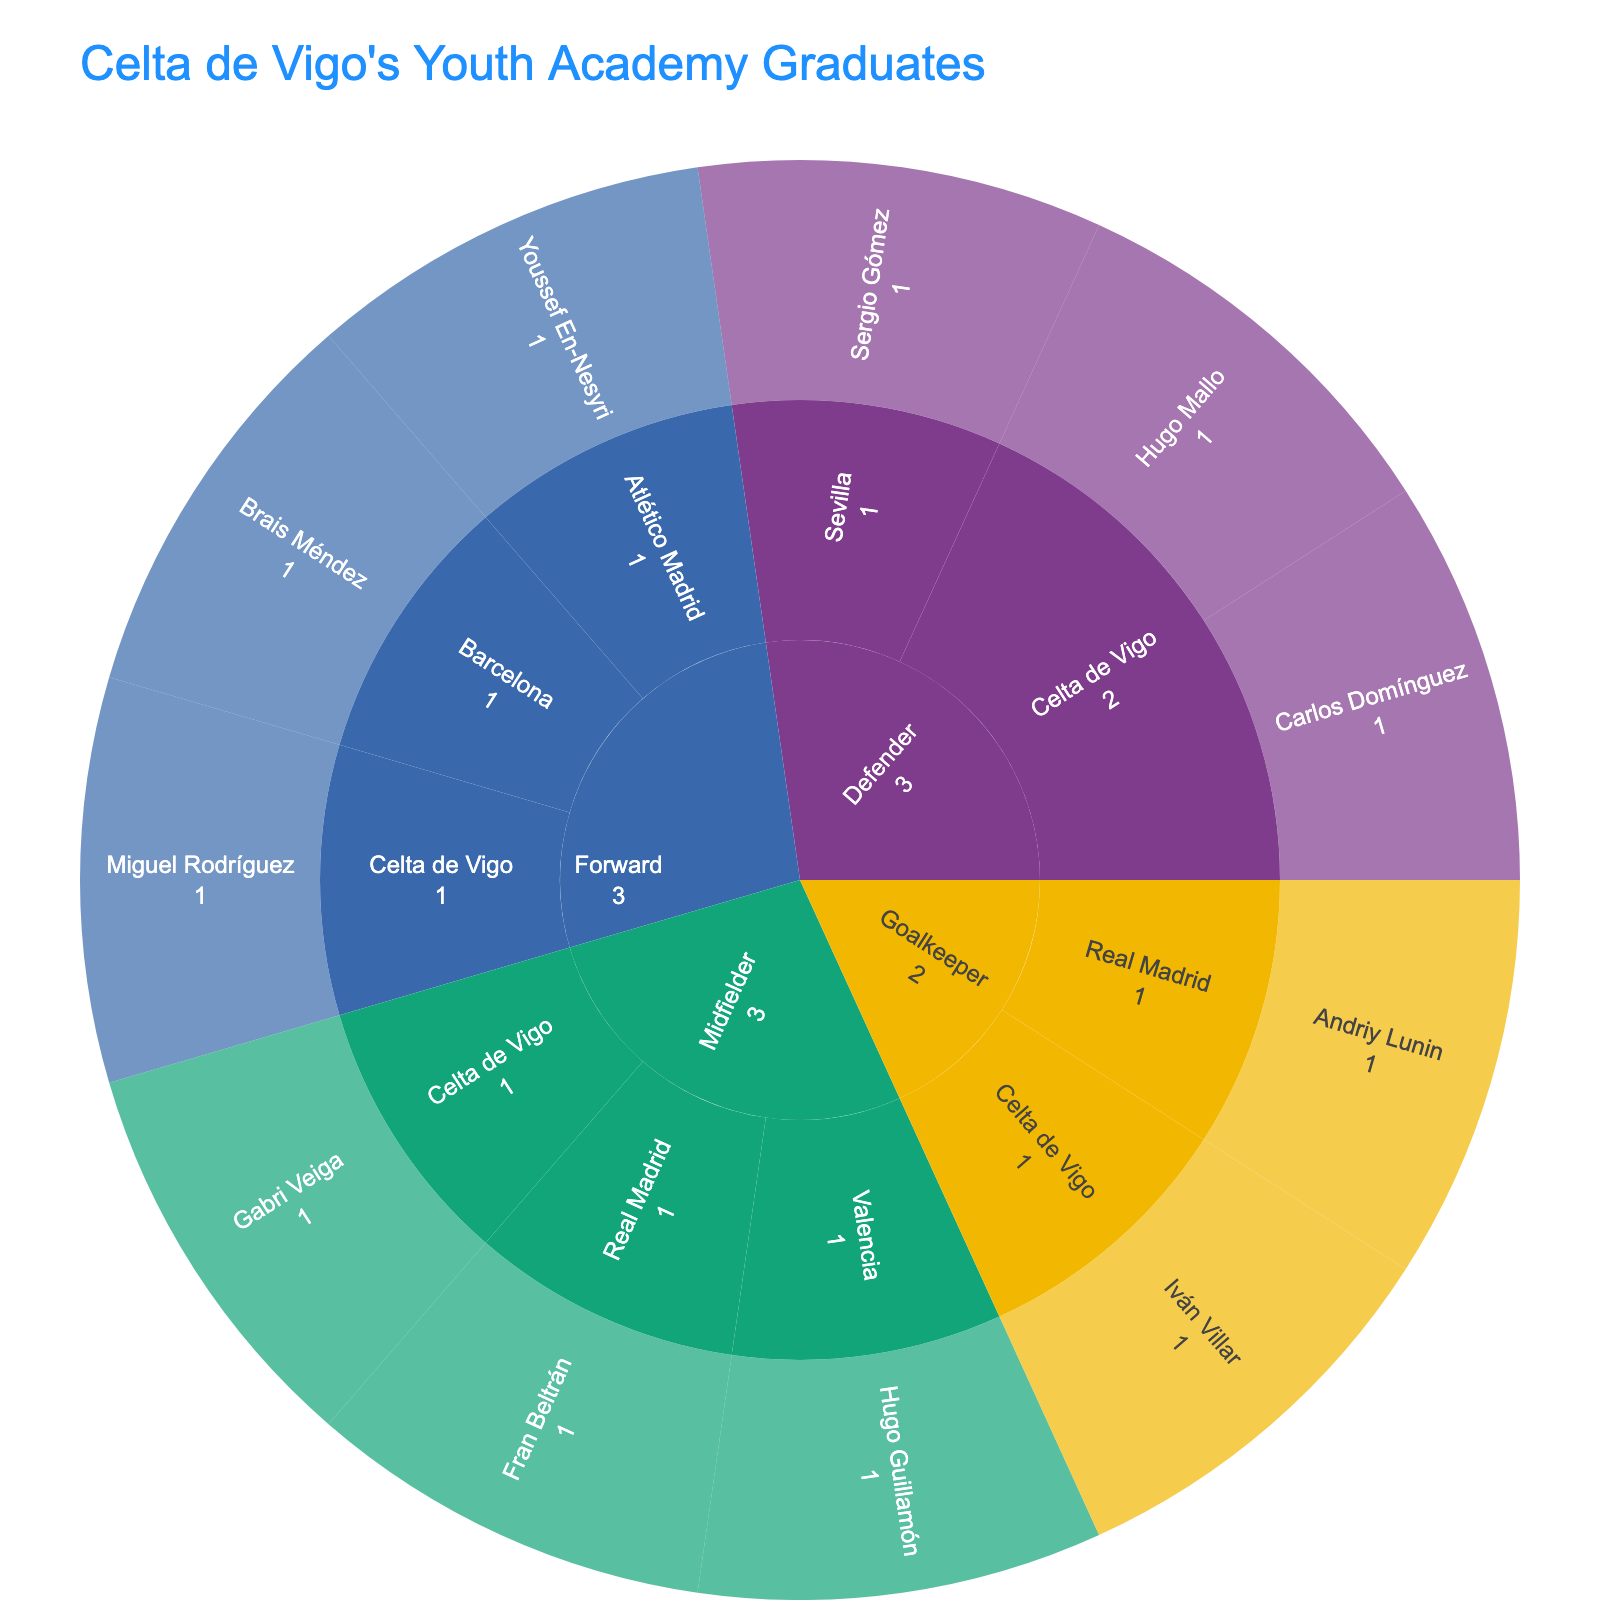What is the title of the Sunburst Plot? The title is usually located at the top of the plot and summarizes the main subject.
Answer: Celta de Vigo's Youth Academy Graduates How many midfielders are currently playing for Celta de Vigo? Navigate through the Midfielder section and check the segment for players at Celta de Vigo. Count the players listed.
Answer: 1 Which player from the youth academy is a goalkeeper at Real Madrid? Navigate to the Goalkeeper section and find the segment for Real Madrid. The player's name will be listed there.
Answer: Andriy Lunin Are there more forwards or defenders currently at Celta de Vigo? Navigate to the Forward and Defender sections and count the players listed under Celta de Vigo in each section. Compare the counts.
Answer: Defenders How many players from the youth academy are currently playing for Real Madrid? Navigate through the plot to identify all segments under Real Madrid across different positions and count the players listed there.
Answer: 2 Compare the number of midfielders at Celta de Vigo versus those at Valencia. Navigate to the Midfielder section and count the players listed under both Celta de Vigo and Valencia segments. Compare the counts.
Answer: 1 vs. 1 Which position has the highest number of players remaining at Celta de Vigo? Look at the sections for each position (Goalkeeper, Defender, Midfielder, Forward) and count the number of players under Celta de Vigo in each. The position with the highest count is the answer.
Answer: Defender Are there any players currently at Barcelona? If so, which position do they play? Navigate through the plot to identify any segments under Barcelona. Check the player's parent segment to find their position.
Answer: Yes, Forward What is the total number of players that have graduated from Celta de Vigo's youth academy and are shown in the plot? Count all the players listed across all segments in the sunburst plot.
Answer: 11 Which non-Celta de Vigo club has the most ex-youth academy players from Celta de Vigo, and how many are there? Navigate through the segments and count the players for each club other than Celta de Vigo. The club with the highest count and the number is the answer.
Answer: Real Madrid, 2 